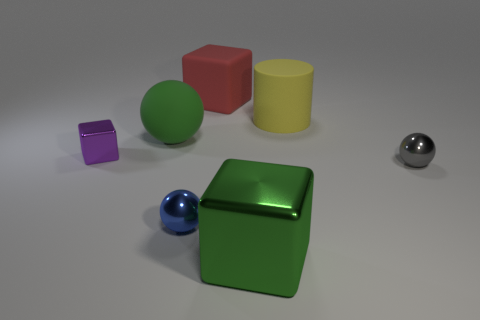Add 2 green objects. How many objects exist? 9 Subtract all small blue balls. How many balls are left? 2 Subtract all gray spheres. How many spheres are left? 2 Subtract all cubes. How many objects are left? 4 Add 2 small purple cubes. How many small purple cubes are left? 3 Add 4 big cyan cubes. How many big cyan cubes exist? 4 Subtract 0 brown cubes. How many objects are left? 7 Subtract 1 blocks. How many blocks are left? 2 Subtract all red balls. Subtract all blue blocks. How many balls are left? 3 Subtract all large blocks. Subtract all green metallic cubes. How many objects are left? 4 